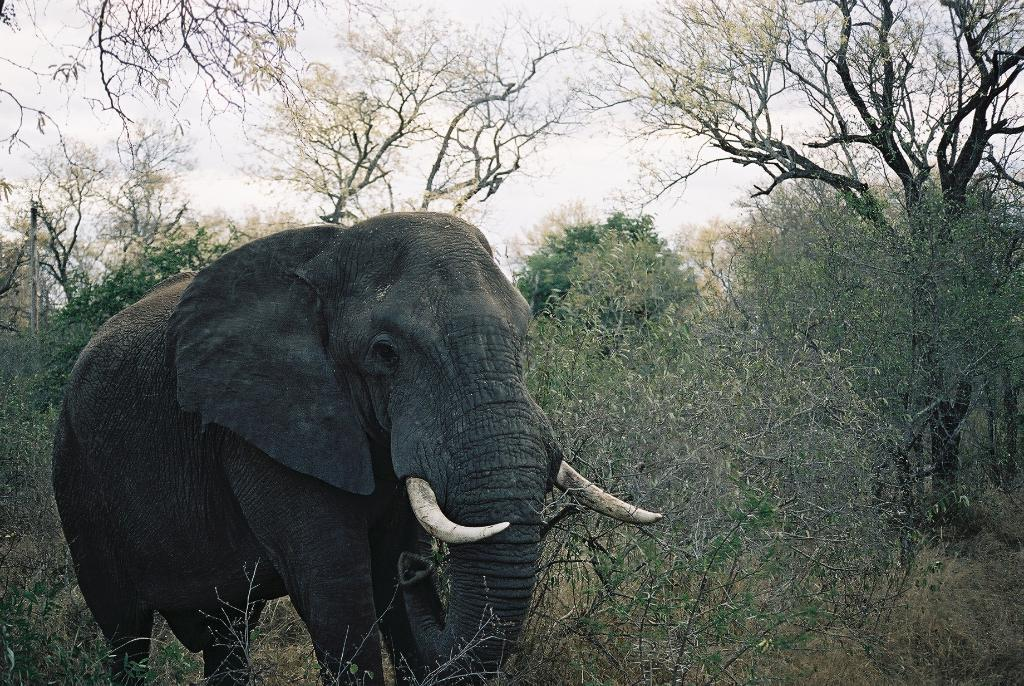What is the main subject in the center of the image? There is an elephant in the center of the image. What can be seen in the background of the image? There are trees, plants, and the sky visible in the background of the image. What is the condition of the sky in the image? Clouds are present in the sky. What is the title of the book the elephant is reading in the image? There is no book or reading material present in the image, as it features an elephant and a natural background. 